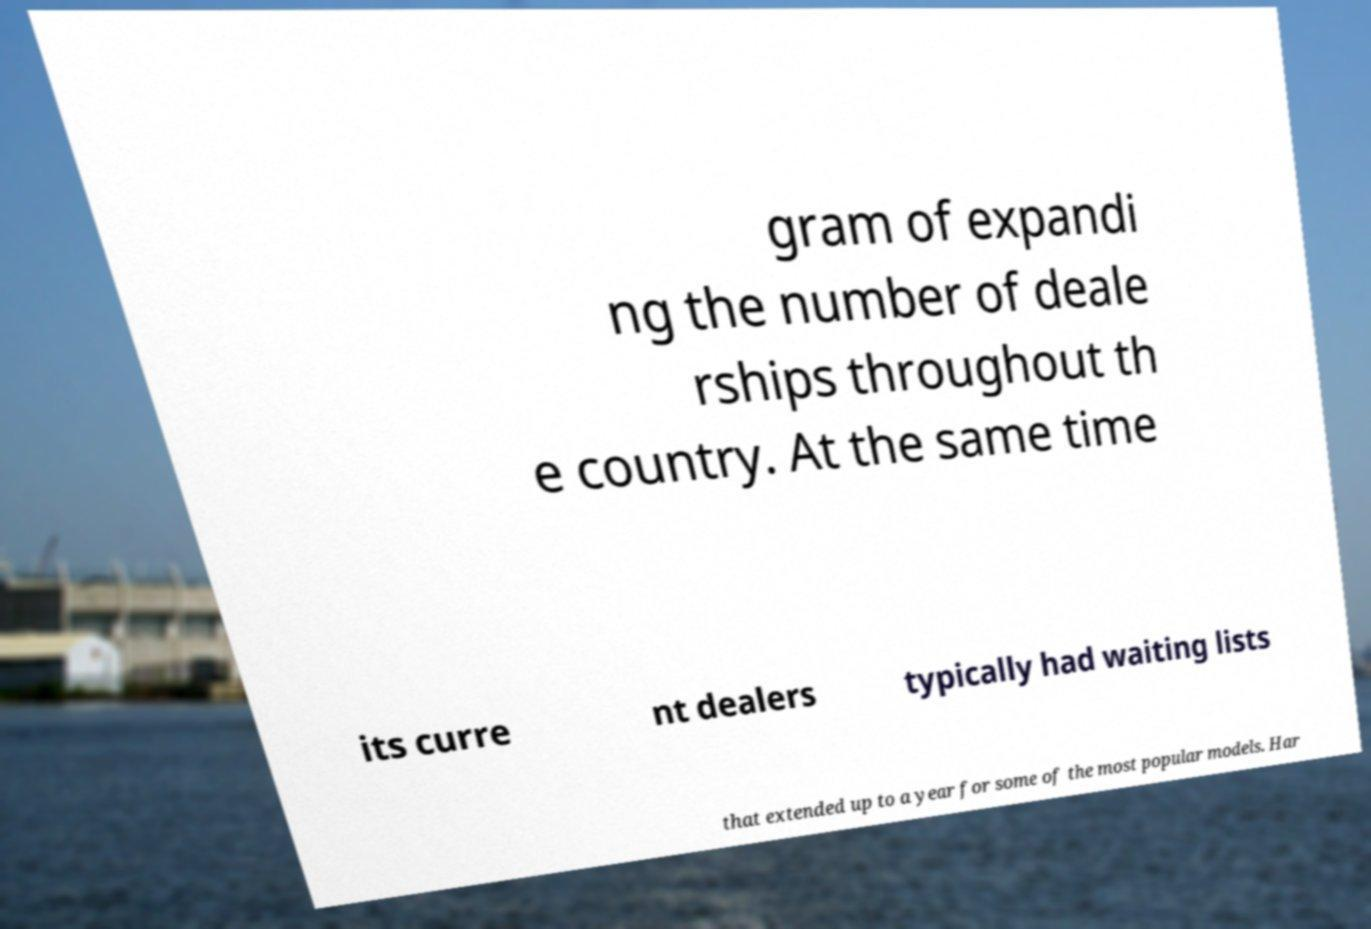Can you read and provide the text displayed in the image?This photo seems to have some interesting text. Can you extract and type it out for me? gram of expandi ng the number of deale rships throughout th e country. At the same time its curre nt dealers typically had waiting lists that extended up to a year for some of the most popular models. Har 